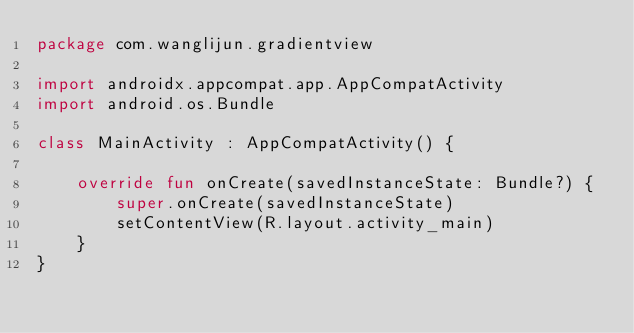Convert code to text. <code><loc_0><loc_0><loc_500><loc_500><_Kotlin_>package com.wanglijun.gradientview

import androidx.appcompat.app.AppCompatActivity
import android.os.Bundle

class MainActivity : AppCompatActivity() {

    override fun onCreate(savedInstanceState: Bundle?) {
        super.onCreate(savedInstanceState)
        setContentView(R.layout.activity_main)
    }
}
</code> 